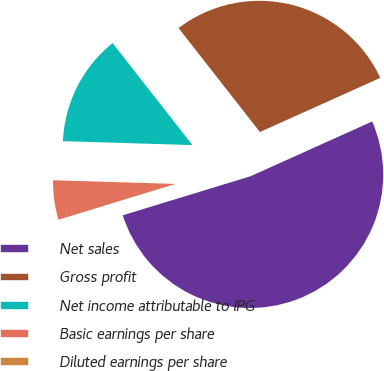<chart> <loc_0><loc_0><loc_500><loc_500><pie_chart><fcel>Net sales<fcel>Gross profit<fcel>Net income attributable to IPG<fcel>Basic earnings per share<fcel>Diluted earnings per share<nl><fcel>52.01%<fcel>28.84%<fcel>13.95%<fcel>5.2%<fcel>0.0%<nl></chart> 